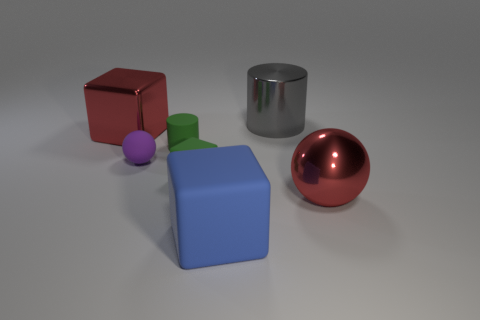Subtract all tiny matte cubes. How many cubes are left? 2 Add 2 big gray metal things. How many objects exist? 9 Subtract all red spheres. How many spheres are left? 1 Subtract 1 cubes. How many cubes are left? 2 Add 6 red metal cubes. How many red metal cubes are left? 7 Add 4 big balls. How many big balls exist? 5 Subtract 0 gray balls. How many objects are left? 7 Subtract all spheres. How many objects are left? 5 Subtract all gray spheres. Subtract all brown cubes. How many spheres are left? 2 Subtract all red cylinders. How many blue cubes are left? 1 